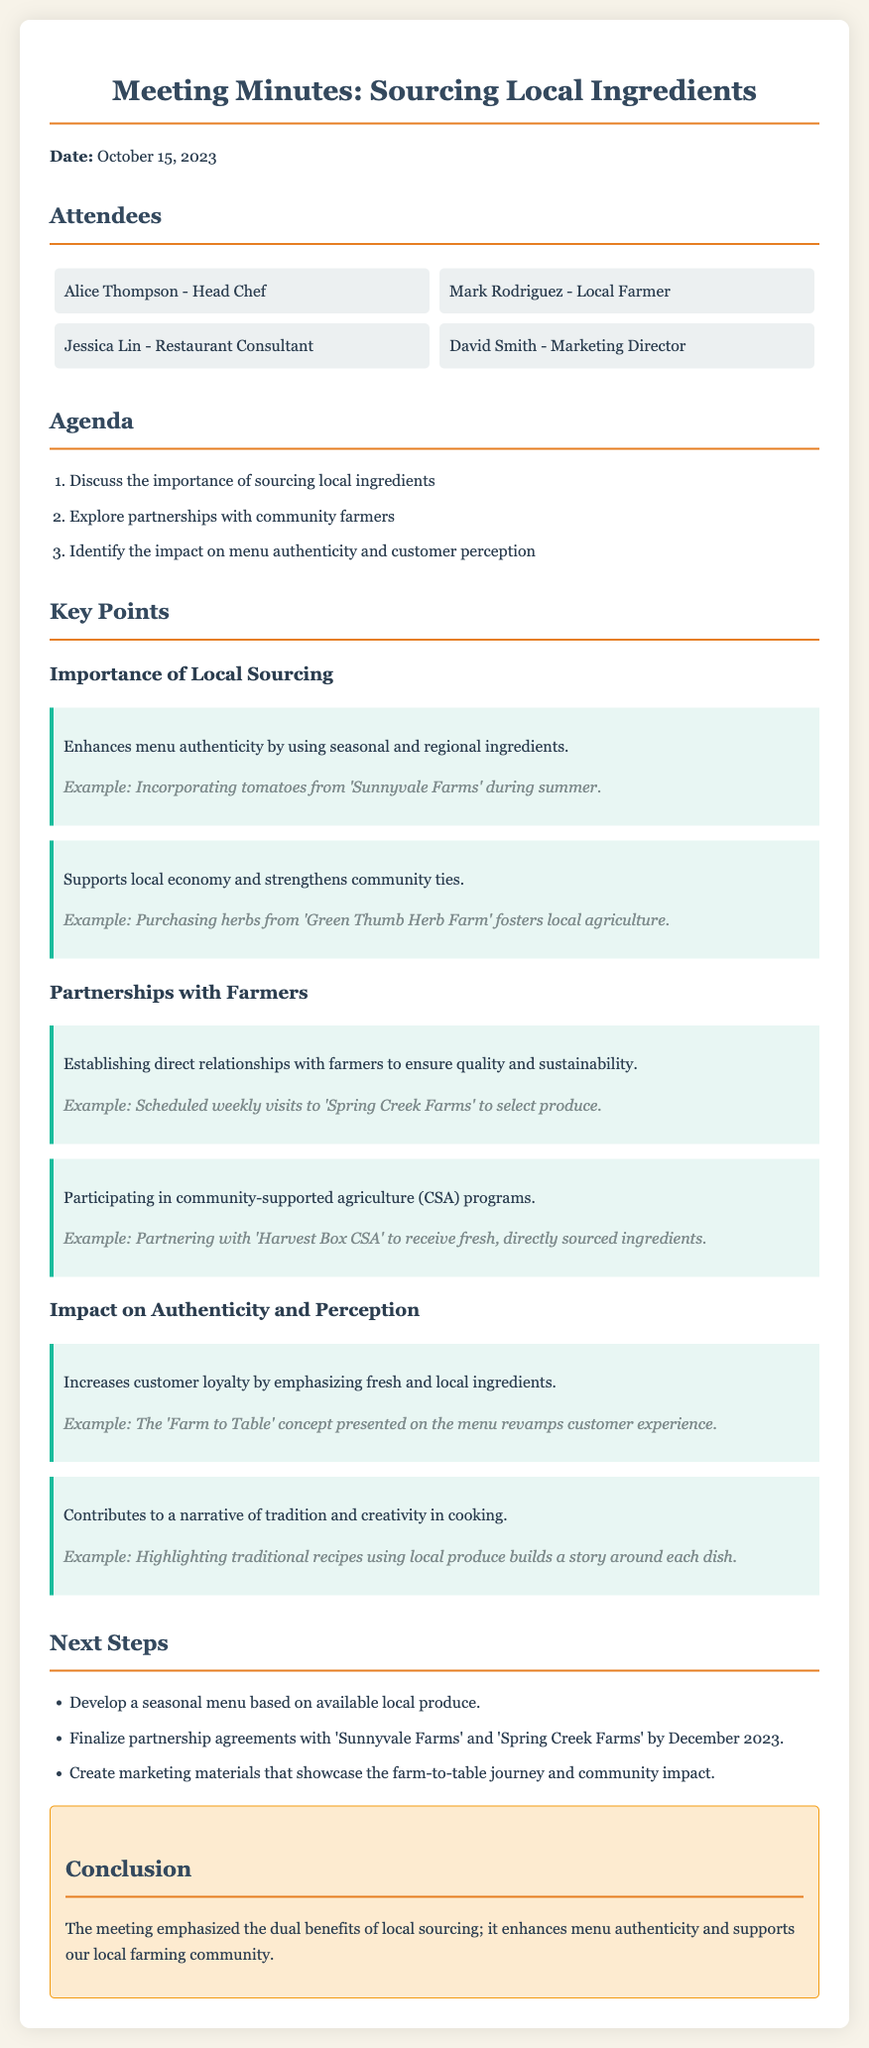What is the date of the meeting? The meeting date is explicitly mentioned at the beginning of the document.
Answer: October 15, 2023 Who is the Head Chef? The document lists the attendees, identifying Alice Thompson as the Head Chef.
Answer: Alice Thompson What is one example of local produce mentioned? The key points section provides examples of local sourcing, including specific farms and their products.
Answer: Tomatoes from 'Sunnyvale Farms' What are the next steps regarding partnerships? The document outlines the specific next steps that include finalizing partnership agreements.
Answer: Finalize partnership agreements with 'Sunnyvale Farms' and 'Spring Creek Farms' by December 2023 How does local sourcing impact customer loyalty? The document mentions that local sourcing increases customer loyalty by emphasizing freshness.
Answer: Increases customer loyalty What is one way to build a narrative around a dish? The key points regarding authenticity discuss how traditional recipes can incorporate local produce for storytelling.
Answer: Highlighting traditional recipes using local produce What are the two key benefits of local sourcing mentioned in the document? The conclusion encapsulates the main outcomes of the meeting regarding local sourcing benefits.
Answer: Enhances menu authenticity and supports our local farming community 